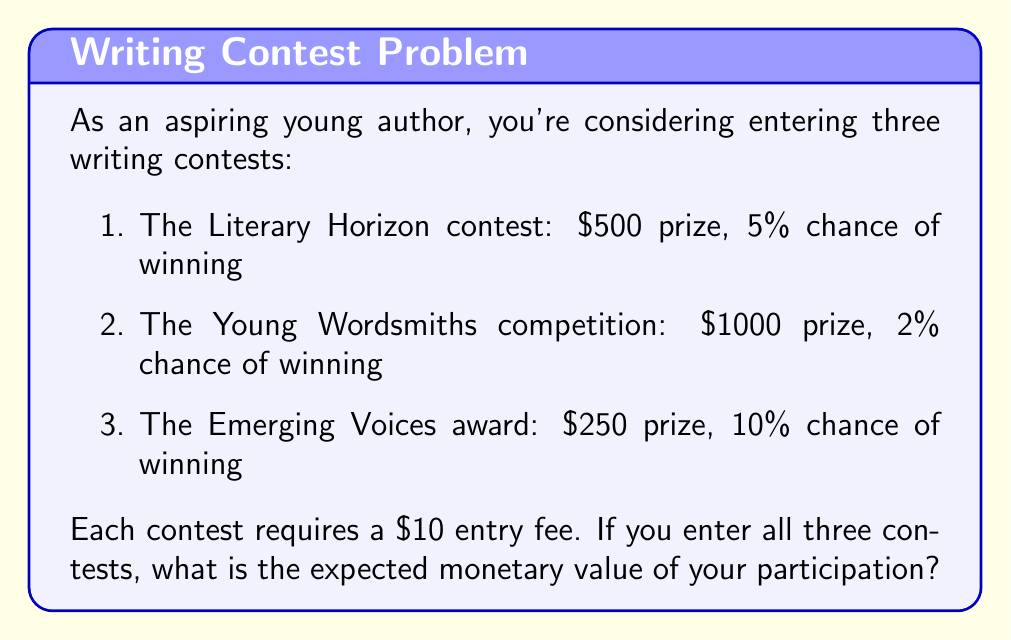Show me your answer to this math problem. To solve this problem, we'll follow these steps:

1. Calculate the expected value of each contest
2. Sum the expected values
3. Subtract the total entry fees

Step 1: Calculate the expected value of each contest

The expected value is calculated by multiplying the prize amount by the probability of winning.

a) Literary Horizon:
   $EV_1 = 500 \times 0.05 = 25$

b) Young Wordsmiths:
   $EV_2 = 1000 \times 0.02 = 20$

c) Emerging Voices:
   $EV_3 = 250 \times 0.10 = 25$

Step 2: Sum the expected values

Total expected value = $EV_1 + EV_2 + EV_3$
$$ \text{Total EV} = 25 + 20 + 25 = 70 $$

Step 3: Subtract the total entry fees

Total entry fees = $10 \times 3 = 30$

Expected monetary value = Total expected value - Total entry fees
$$ \text{Expected monetary value} = 70 - 30 = 40 $$

Therefore, the expected monetary value of entering all three contests is $40.
Answer: $40 